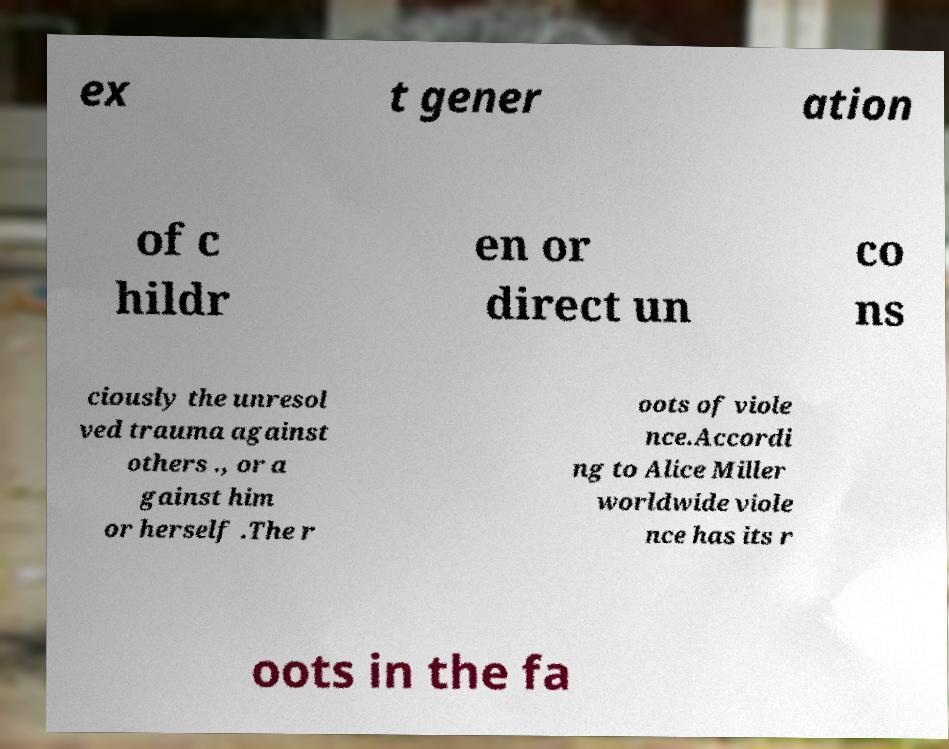Could you assist in decoding the text presented in this image and type it out clearly? ex t gener ation of c hildr en or direct un co ns ciously the unresol ved trauma against others ., or a gainst him or herself .The r oots of viole nce.Accordi ng to Alice Miller worldwide viole nce has its r oots in the fa 